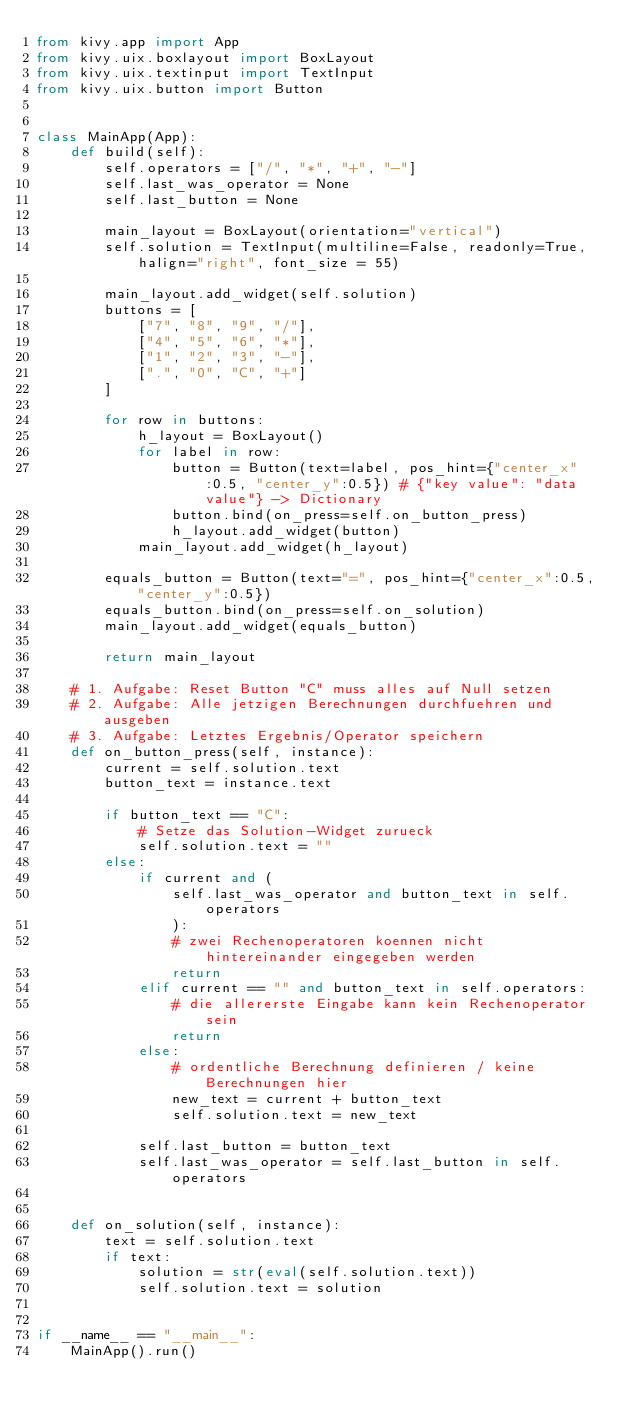<code> <loc_0><loc_0><loc_500><loc_500><_Python_>from kivy.app import App
from kivy.uix.boxlayout import BoxLayout
from kivy.uix.textinput import TextInput
from kivy.uix.button import Button


class MainApp(App):
    def build(self):
        self.operators = ["/", "*", "+", "-"]
        self.last_was_operator = None
        self.last_button = None

        main_layout = BoxLayout(orientation="vertical")
        self.solution = TextInput(multiline=False, readonly=True, halign="right", font_size = 55)

        main_layout.add_widget(self.solution)
        buttons = [
            ["7", "8", "9", "/"], 
            ["4", "5", "6", "*"],
            ["1", "2", "3", "-"],
            [".", "0", "C", "+"]
        ]

        for row in buttons:
            h_layout = BoxLayout()
            for label in row:
                button = Button(text=label, pos_hint={"center_x":0.5, "center_y":0.5}) # {"key value": "data value"} -> Dictionary
                button.bind(on_press=self.on_button_press)
                h_layout.add_widget(button)
            main_layout.add_widget(h_layout)
        
        equals_button = Button(text="=", pos_hint={"center_x":0.5, "center_y":0.5})
        equals_button.bind(on_press=self.on_solution)
        main_layout.add_widget(equals_button)

        return main_layout

    # 1. Aufgabe: Reset Button "C" muss alles auf Null setzen
    # 2. Aufgabe: Alle jetzigen Berechnungen durchfuehren und ausgeben
    # 3. Aufgabe: Letztes Ergebnis/Operator speichern
    def on_button_press(self, instance):
        current = self.solution.text
        button_text = instance.text

        if button_text == "C":
            # Setze das Solution-Widget zurueck
            self.solution.text = ""
        else:
            if current and (
                self.last_was_operator and button_text in self.operators
                ):
                # zwei Rechenoperatoren koennen nicht hintereinander eingegeben werden
                return
            elif current == "" and button_text in self.operators:
                # die allererste Eingabe kann kein Rechenoperator sein
                return
            else:
                # ordentliche Berechnung definieren / keine Berechnungen hier
                new_text = current + button_text
                self.solution.text = new_text

            self.last_button = button_text
            self.last_was_operator = self.last_button in self.operators

            
    def on_solution(self, instance):
        text = self.solution.text 
        if text:
            solution = str(eval(self.solution.text))
            self.solution.text = solution


if __name__ == "__main__":
    MainApp().run()

</code> 